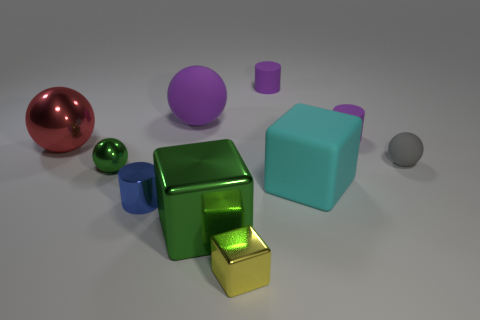Do the big metallic thing that is in front of the tiny gray matte object and the small metallic object that is left of the blue shiny cylinder have the same color?
Keep it short and to the point. Yes. How many big shiny things have the same color as the tiny metallic ball?
Make the answer very short. 1. How many other things are the same color as the large matte sphere?
Your answer should be compact. 2. Are there more big green objects than green objects?
Your answer should be very brief. No. What is the material of the red ball?
Make the answer very short. Metal. There is a block behind the blue cylinder; is it the same size as the tiny matte sphere?
Keep it short and to the point. No. What is the size of the green object that is behind the large cyan matte thing?
Your answer should be compact. Small. How many red shiny things are there?
Your response must be concise. 1. Is the big rubber cube the same color as the tiny metal cube?
Your answer should be very brief. No. What is the color of the thing that is left of the big purple matte ball and in front of the cyan block?
Make the answer very short. Blue. 